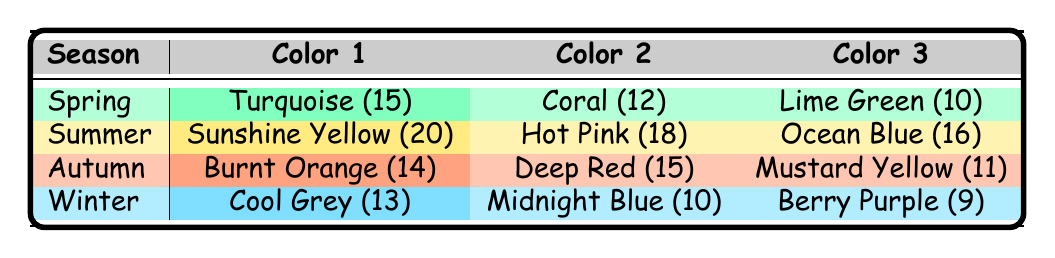What color has the highest frequency in Spring? In the Spring season, I can check the table and see that Turquoise has a frequency of 15, which is higher than Coral (12) and Lime Green (10).
Answer: Turquoise Which season features the color Hot Pink? Looking at the table, Hot Pink appears in the Summer season with a frequency of 18.
Answer: Summer What is the total frequency of Autumn colors? To find the total frequency for Autumn, I need to sum up the frequencies: Burnt Orange (14) + Deep Red (15) + Mustard Yellow (11) = 40.
Answer: 40 Does Winter have any colors with a frequency greater than 12? In Winter, the colors listed are Cool Grey (13), Midnight Blue (10), and Berry Purple (9). Among these, Cool Grey is the only color exceeding a frequency of 12.
Answer: Yes What is the difference between the maximum and minimum frequencies in Summer? In the Summer season, the colors and their frequencies are Sunshine Yellow (20), Hot Pink (18), and Ocean Blue (16). The maximum frequency is 20 (Sunshine Yellow) and the minimum is 16 (Ocean Blue). The difference is 20 - 16 = 4.
Answer: 4 Is Mustard Yellow the least used color in Autumn? In Autumn, the frequencies are Burnt Orange (14), Deep Red (15), and Mustard Yellow (11). The frequency of Mustard Yellow is indeed the lowest among the colors listed for Autumn.
Answer: Yes What is the average frequency of colors used in Winter? For Winter, the colors and frequencies are Cool Grey (13), Midnight Blue (10), and Berry Purple (9). First, I sum them up: 13 + 10 + 9 = 32. Then, I divide by the number of color entries: 32 / 3 = approximately 10.67.
Answer: 10.67 Which season has the most total colors used? Each season in the table has three colors listed (Spring, Summer, Autumn, Winter). Therefore, they all have an equal number of colors.
Answer: All seasons have the same number of colors 